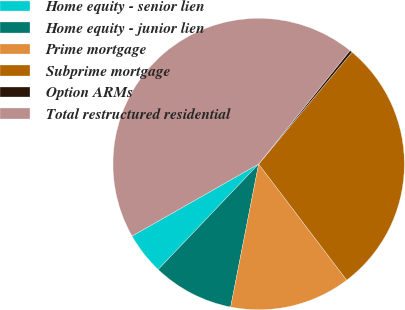<chart> <loc_0><loc_0><loc_500><loc_500><pie_chart><fcel>Home equity - senior lien<fcel>Home equity - junior lien<fcel>Prime mortgage<fcel>Subprime mortgage<fcel>Option ARMs<fcel>Total restructured residential<nl><fcel>4.66%<fcel>9.03%<fcel>13.4%<fcel>28.61%<fcel>0.29%<fcel>44.01%<nl></chart> 